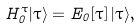Convert formula to latex. <formula><loc_0><loc_0><loc_500><loc_500>H _ { 0 } ^ { \tau } | \tau \rangle = E _ { 0 } [ \tau ] \, | \tau \rangle ,</formula> 